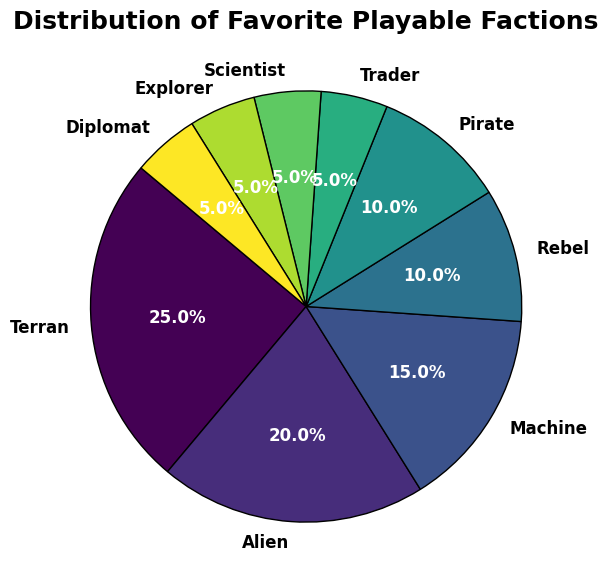What's the percentage difference between Terran and Alien factions? Terran has 25% and Alien has 20%. The difference is 25% - 20% = 5%.
Answer: 5% Which faction has the smallest percentage, and what's that percentage? The factions with the smallest percentage are Trader, Scientist, Explorer, and Diplomat, all with 5%.
Answer: Trader, Scientist, Explorer, Diplomat, 5% Are Terran and Alien factions together less than the sum of the Machine and Rebel factions? Terran (25%) + Alien (20%) = 45%, while Machine (15%) + Rebel (10%) = 25%. Since 45% is not less than 25%, the answer is no.
Answer: No How many factions have a percentage of 10% or more? Terran, Alien, Machine, Rebel, and Pirate factions have percentages of 10% or more. There are 5 factions in total.
Answer: 5 What is the average percentage of the bottom four least favorite factions? The bottom four factions are Trader (5%), Scientist (5%), Explorer (5%), and Diplomat (5%). The average is (5% + 5% + 5% + 5%) / 4 = 5%.
Answer: 5% Which two factions together make up 30%? Machine (15%) and Rebel (10%) together make 25%, which is closest to 30%.
Answer: Machine, Rebel Between which two factions is the largest percentage difference? Terran (25%) and the bottom four factions (Trader, Scientist, Explorer, Diplomat with 5% each) have the largest percentage difference of 20%.
Answer: Terran and bottom four factions What proportion of the total is contributed by factions with a percentage 5%? There are five factions each contributing 5%, resulting in a total of 5 * 5% = 25%.
Answer: 25% Which faction is directly opposite the Scientist faction in the pie chart? In the pie chart, the Scientist faction is at 5%, and starting at 140 degrees, this segment is opposite to Alien (20%).
Answer: Alien 